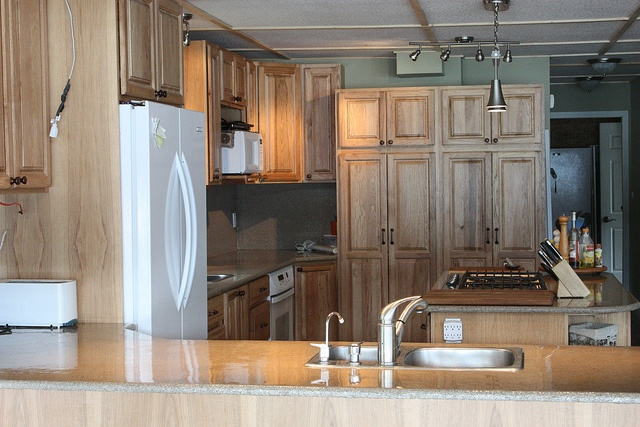Describe the objects in this image and their specific colors. I can see refrigerator in brown, darkgray, and lightblue tones, sink in brown, lightgray, darkgray, and gray tones, microwave in brown, darkgray, lightgray, and gray tones, oven in brown, gray, and black tones, and sink in brown, lightgray, gray, and darkgray tones in this image. 